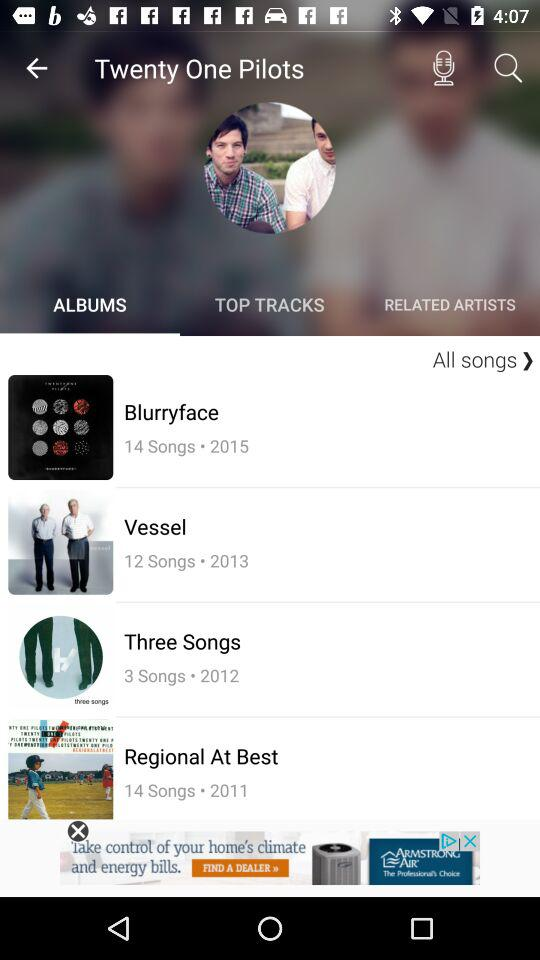How many songs does the "Blurryface" album have? The "Blurryface" album has 14 songs. 